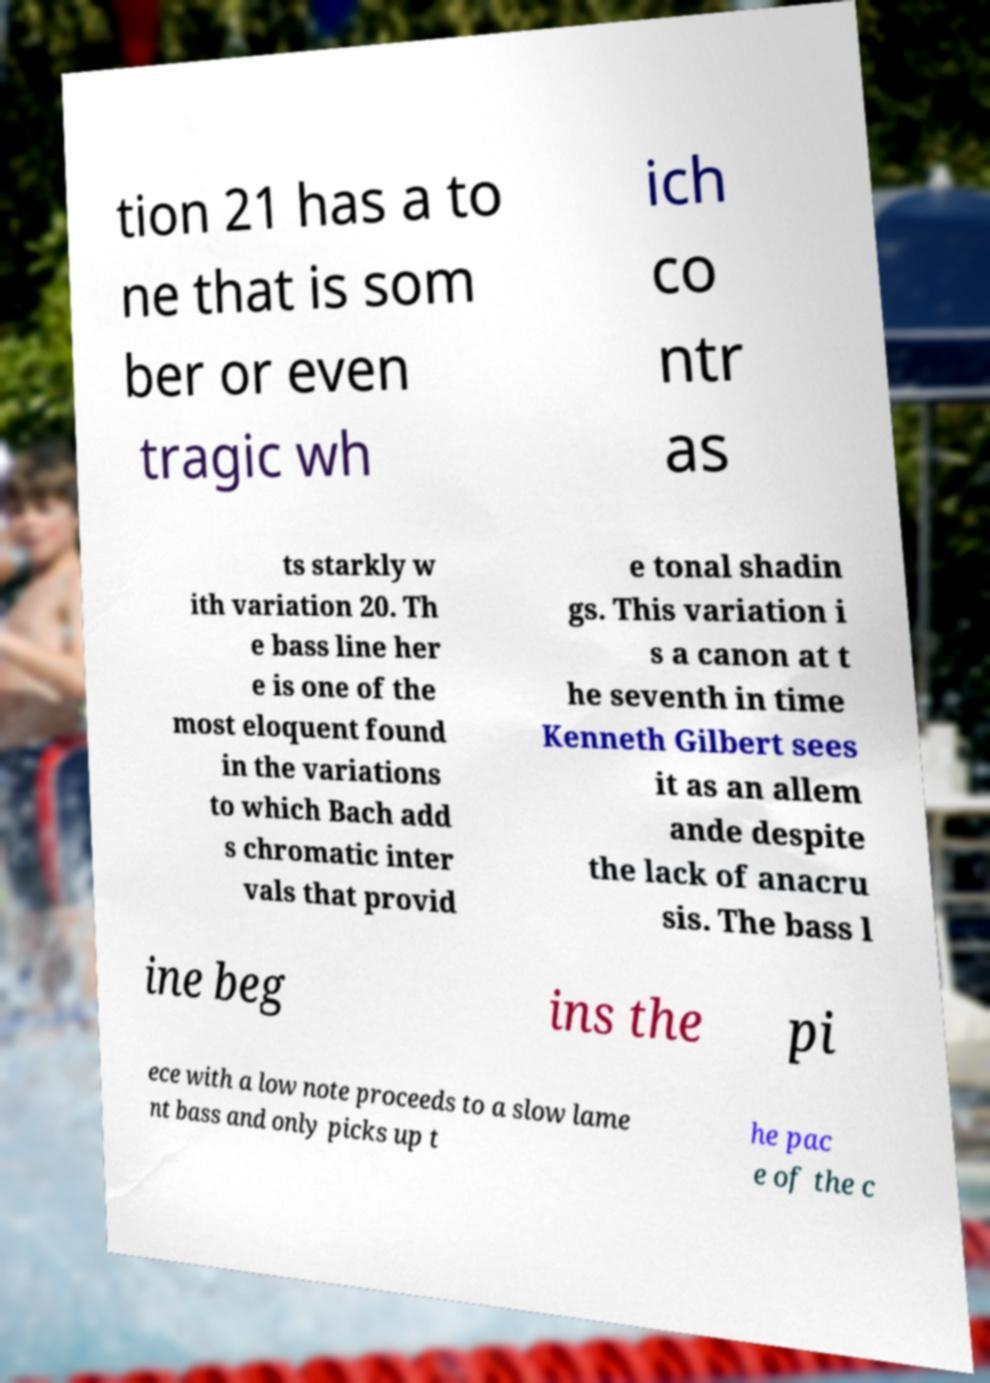What messages or text are displayed in this image? I need them in a readable, typed format. tion 21 has a to ne that is som ber or even tragic wh ich co ntr as ts starkly w ith variation 20. Th e bass line her e is one of the most eloquent found in the variations to which Bach add s chromatic inter vals that provid e tonal shadin gs. This variation i s a canon at t he seventh in time Kenneth Gilbert sees it as an allem ande despite the lack of anacru sis. The bass l ine beg ins the pi ece with a low note proceeds to a slow lame nt bass and only picks up t he pac e of the c 